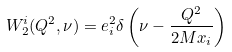<formula> <loc_0><loc_0><loc_500><loc_500>W _ { 2 } ^ { i } ( Q ^ { 2 } , \nu ) = e _ { i } ^ { 2 } \delta \left ( \nu - \frac { Q ^ { 2 } } { 2 M x _ { i } } \right )</formula> 